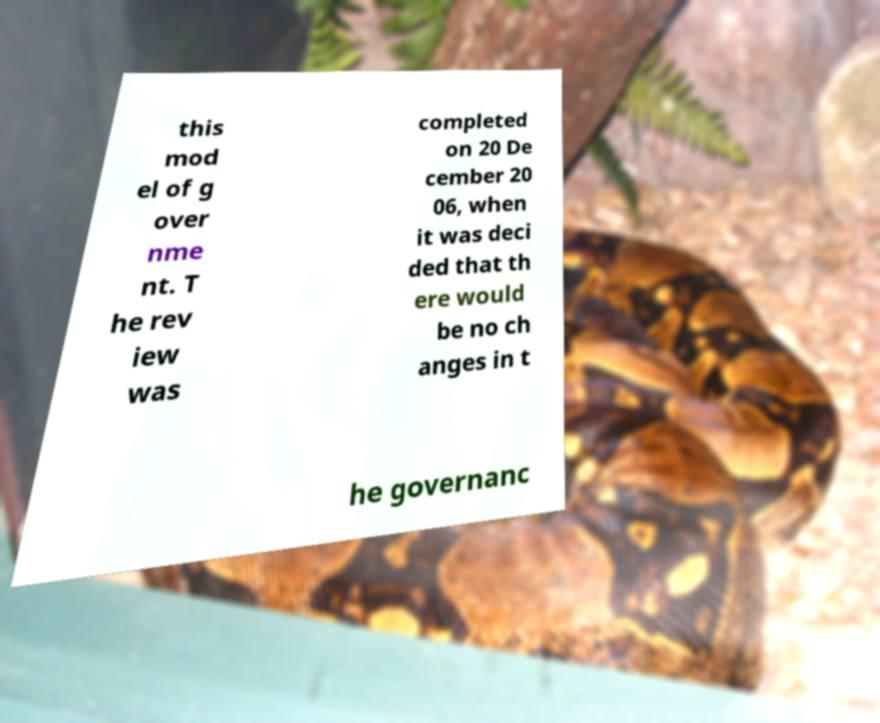There's text embedded in this image that I need extracted. Can you transcribe it verbatim? this mod el of g over nme nt. T he rev iew was completed on 20 De cember 20 06, when it was deci ded that th ere would be no ch anges in t he governanc 